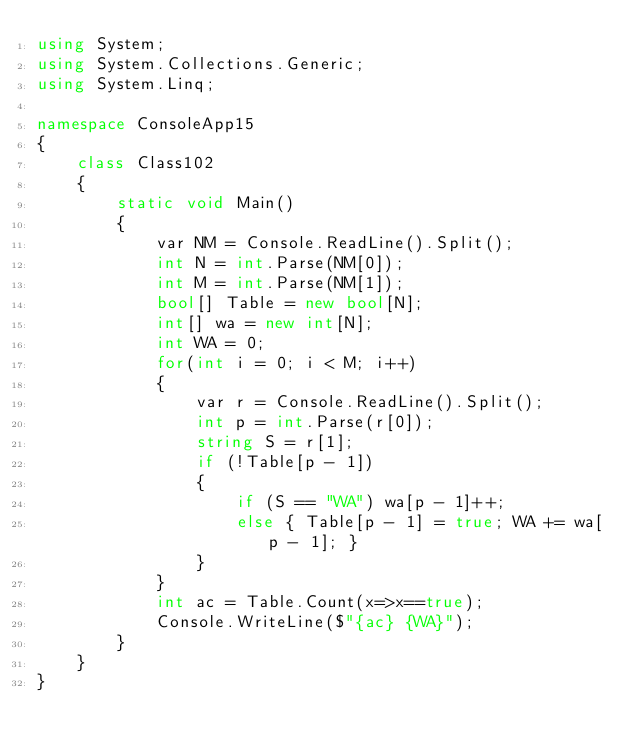<code> <loc_0><loc_0><loc_500><loc_500><_C#_>using System;
using System.Collections.Generic;
using System.Linq;

namespace ConsoleApp15
{
    class Class102
    {
        static void Main()
        {
            var NM = Console.ReadLine().Split();
            int N = int.Parse(NM[0]);
            int M = int.Parse(NM[1]);
            bool[] Table = new bool[N];
            int[] wa = new int[N];
            int WA = 0;
            for(int i = 0; i < M; i++)
            {
                var r = Console.ReadLine().Split();
                int p = int.Parse(r[0]);
                string S = r[1];
                if (!Table[p - 1])
                {
                    if (S == "WA") wa[p - 1]++;
                    else { Table[p - 1] = true; WA += wa[p - 1]; }
                }
            }
            int ac = Table.Count(x=>x==true);
            Console.WriteLine($"{ac} {WA}");
        }
    }
}
</code> 